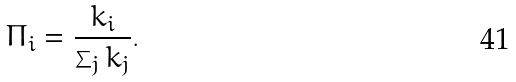Convert formula to latex. <formula><loc_0><loc_0><loc_500><loc_500>\Pi _ { i } = \frac { k _ { i } } { \sum _ { j } k _ { j } } .</formula> 